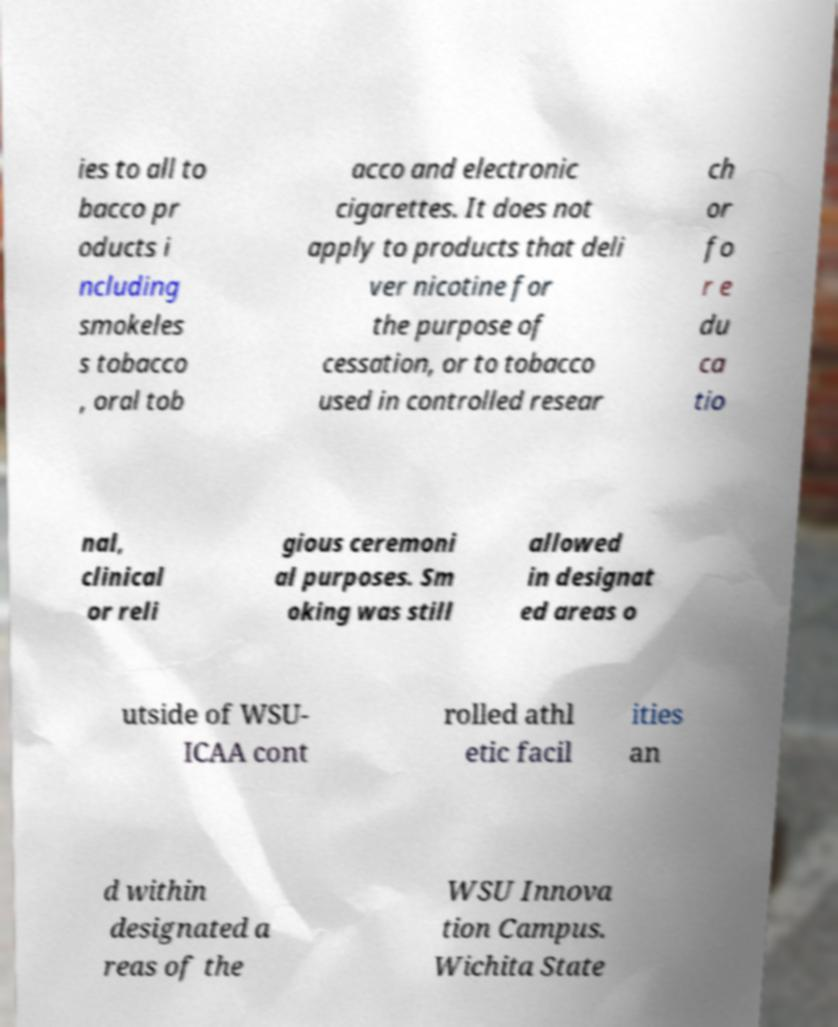Can you read and provide the text displayed in the image?This photo seems to have some interesting text. Can you extract and type it out for me? ies to all to bacco pr oducts i ncluding smokeles s tobacco , oral tob acco and electronic cigarettes. It does not apply to products that deli ver nicotine for the purpose of cessation, or to tobacco used in controlled resear ch or fo r e du ca tio nal, clinical or reli gious ceremoni al purposes. Sm oking was still allowed in designat ed areas o utside of WSU- ICAA cont rolled athl etic facil ities an d within designated a reas of the WSU Innova tion Campus. Wichita State 